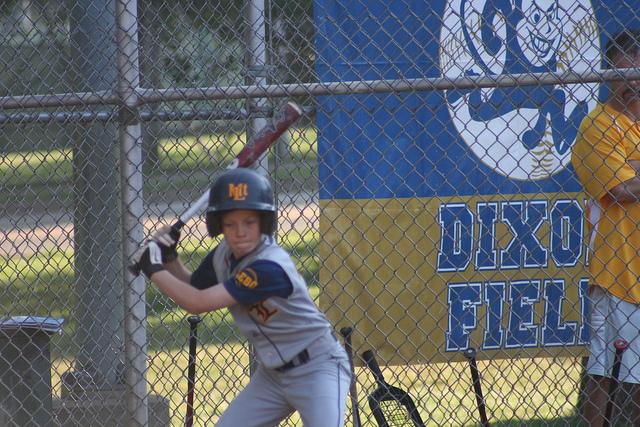What brand is represented on the boy's clothing?
Concise answer only. Dixon. Is this a professional baseball team?
Be succinct. No. Is he about to hit the ball?
Keep it brief. Yes. What color is this kids helmet?
Concise answer only. Blue. What number is on the player's shirt?
Short answer required. 0. What do the signs say?
Answer briefly. Dixon field. What kind of ball is he hitting?
Short answer required. Baseball. Is the guy smiling?
Concise answer only. No. Is the child ready to hit a real ball?
Give a very brief answer. Yes. 